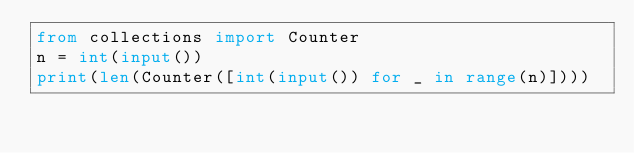Convert code to text. <code><loc_0><loc_0><loc_500><loc_500><_Python_>from collections import Counter
n = int(input())
print(len(Counter([int(input()) for _ in range(n)])))</code> 